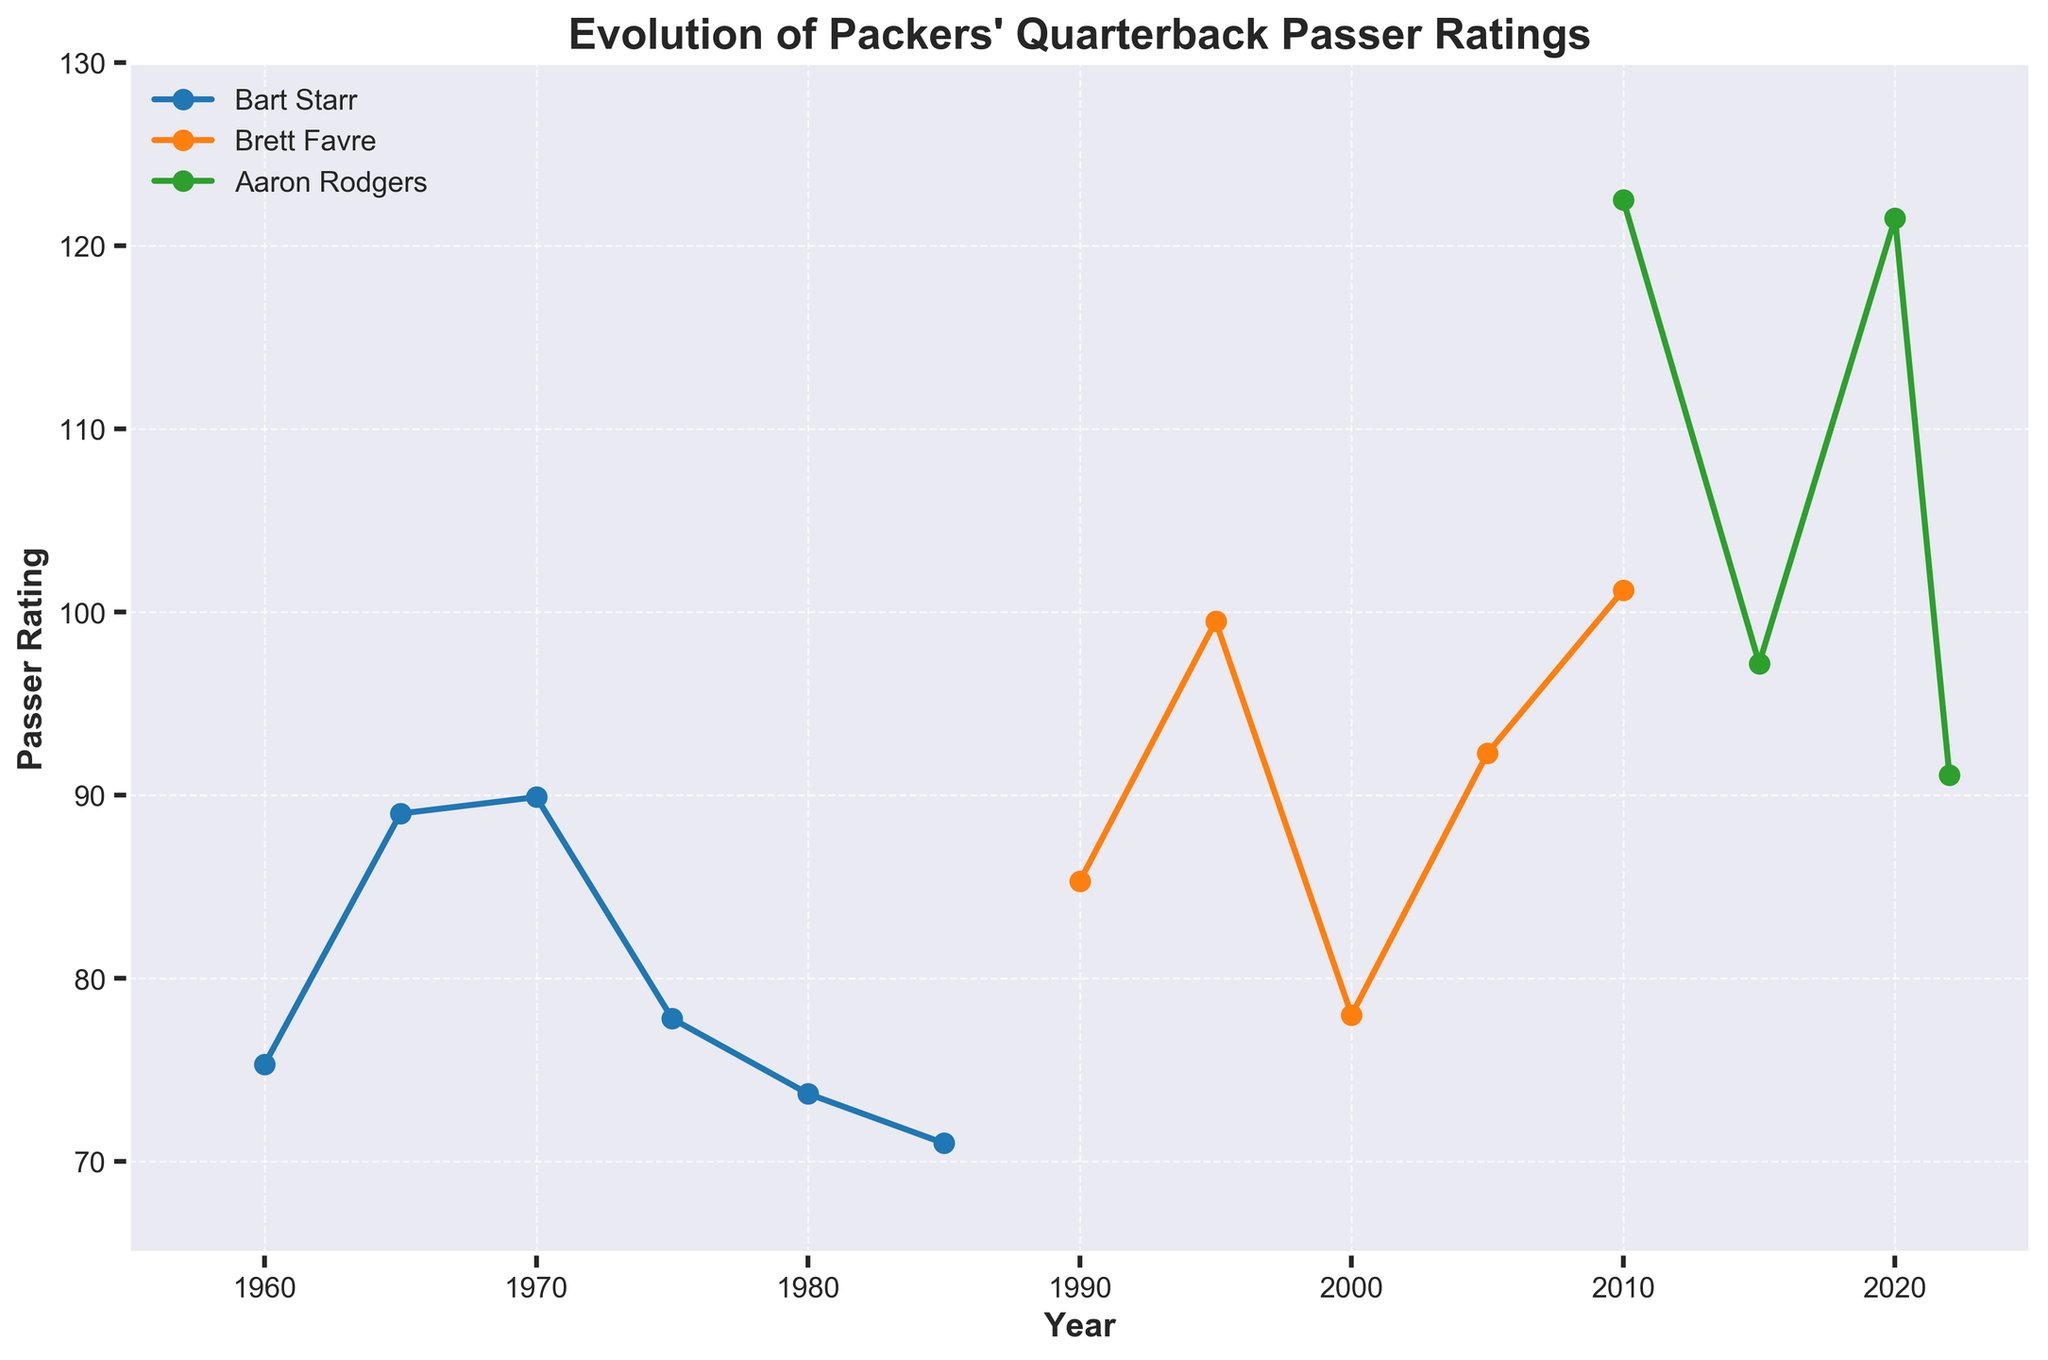What is the highest passer rating recorded by Bart Starr? Identify the maximum value in Bart Starr's data points on the plot, which is 89.9 in 1970.
Answer: 89.9 Which quarterback has the highest passer rating in 2020? Look at the data point for the year 2020 and note that Aaron Rodgers has the highest passer rating of 121.5.
Answer: Aaron Rodgers What is the difference in passer ratings between Bart Starr in 1970 and Brett Favre in 1995? Note that Bart Starr's passer rating in 1970 is 89.9 and Brett Favre's in 1995 is 99.5. The difference is 99.5 - 89.9 = 9.6.
Answer: 9.6 How did Aaron Rodgers' passer rating change from 2010 to 2022? In 2010, Aaron Rodgers' passer rating was 122.5, and in 2022 it was 91.1. The change is 91.1 - 122.5 = -31.4.
Answer: -31.4 Who had a higher passer rating in 2010, Brett Favre or Aaron Rodgers? Compare the passer ratings in 2010. Brett Favre's is 101.2, while Aaron Rodgers' is 122.5. Thus, Aaron Rodgers had a higher rating.
Answer: Aaron Rodgers Between 1960 and 1970, what trend can be observed in Bart Starr's passer ratings? Observe the data points for Bart Starr from 1960 to 1970. The ratings increase from 75.3 in 1960 to 89.9 in 1970, indicating an upward trend over the decade.
Answer: Upward trend Compare Brett Favre's passer rating in 1990 and 2000. Which year had a better rating? Brett Favre's passer rating in 1990 is 85.3, while in 2000 it is 78.0. Therefore, he had a better rating in 1990.
Answer: 1990 